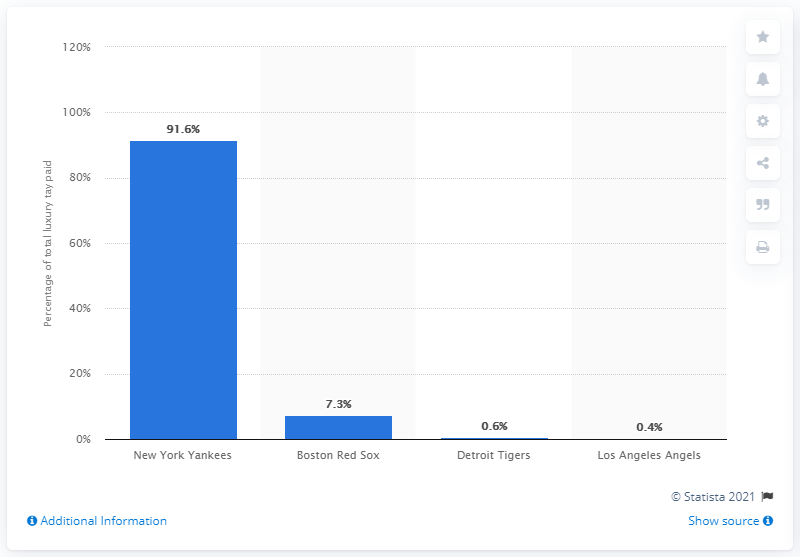Outline some significant characteristics in this image. The tallest bar in the x-axis is referred to as New York Yankees. The sum of the Boston Red Sox, Detroit Tigers, and Los Angeles Angels is 8.3. The Boston Red Sox have paid a significant portion of the total luxury tax. Specifically, 7.3... has been paid by the team. 